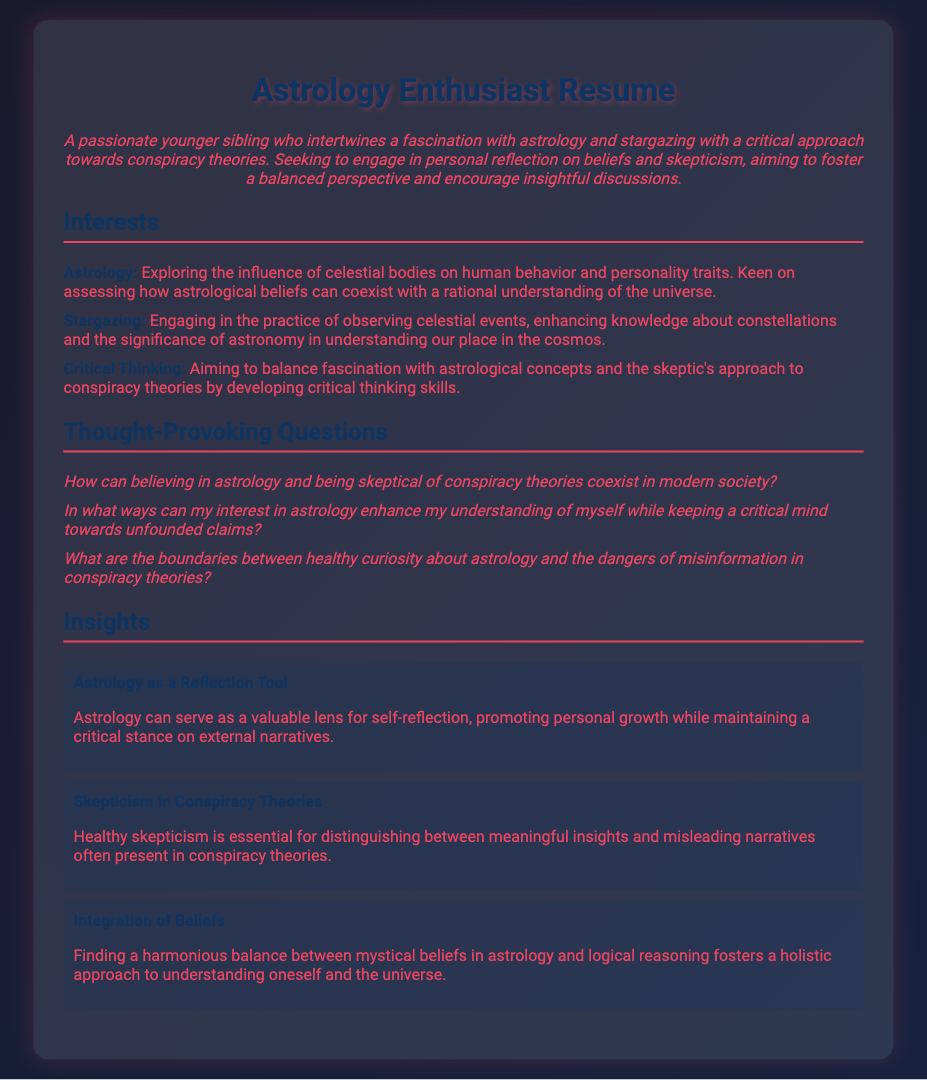What is the title of the document? The title appears at the top of the document and indicates its main focus.
Answer: Astrology Enthusiast Resume How many interests are listed in the document? The number of interests can be counted in the Interests section of the document.
Answer: 3 What color represents the subtitle in the summary? The color used for the summary is identified in the document's style or by visual observation.
Answer: #e94560 What is one of the thought-provoking questions included? The document lists multiple thought-provoking questions, and the specific question can be directly referenced.
Answer: How can believing in astrology and being skeptical of conspiracy theories coexist in modern society? What is the main goal mentioned in the summary? The summary indicates a primary objective that aligns with the author's aspirations as described.
Answer: Foster a balanced perspective What does the "Astrology as a Reflection Tool" insight suggest? This insight provides a specific view on how astrology can be perceived, directly stated in the document.
Answer: Valuable lens for self-reflection Which interest relates to observing celestial events? The specific interest is detailed in the Interests section of the document.
Answer: Stargazing What is the primary color of the document's background? The overall background color can be inferred from the document’s design aesthetics.
Answer: #1a1a2e 